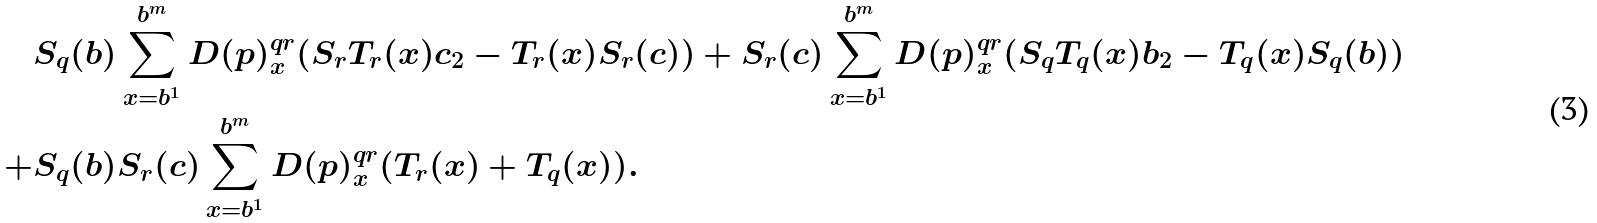<formula> <loc_0><loc_0><loc_500><loc_500>& S _ { q } ( b ) \sum _ { x = b ^ { 1 } } ^ { b ^ { m } } D ( p ) ^ { q r } _ { x } ( S _ { r } T _ { r } ( x ) c _ { 2 } - T _ { r } ( x ) S _ { r } ( c ) ) + S _ { r } ( c ) \sum _ { x = b ^ { 1 } } ^ { b ^ { m } } D ( p ) ^ { q r } _ { x } ( S _ { q } T _ { q } ( x ) b _ { 2 } - T _ { q } ( x ) S _ { q } ( b ) ) \\ + & S _ { q } ( b ) S _ { r } ( c ) \sum _ { x = b ^ { 1 } } ^ { b ^ { m } } D ( p ) ^ { q r } _ { x } ( T _ { r } ( x ) + T _ { q } ( x ) ) .</formula> 